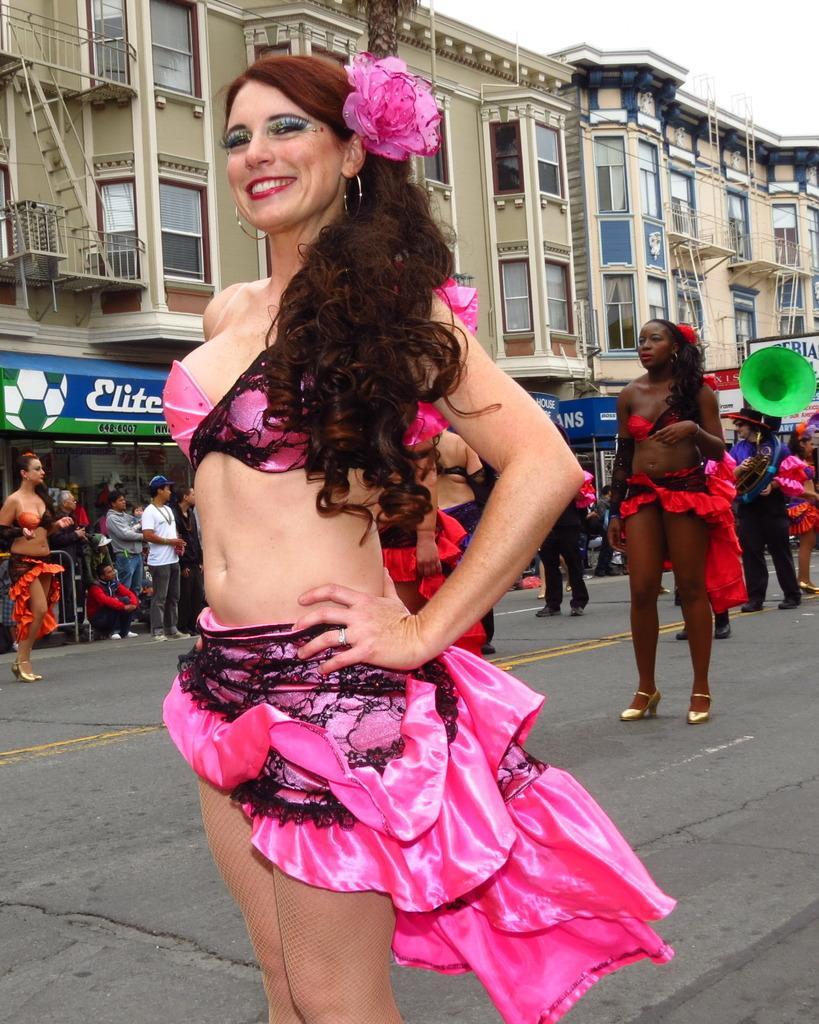Please provide a concise description of this image. In this picture I can see there is a woman standing here and she is smiling and she is wearing a pink color top and a skirt and in the backdrop there are few women standing and they are wearing red color top and skirt and there are men standing and there are buildings and the sky is clear. 